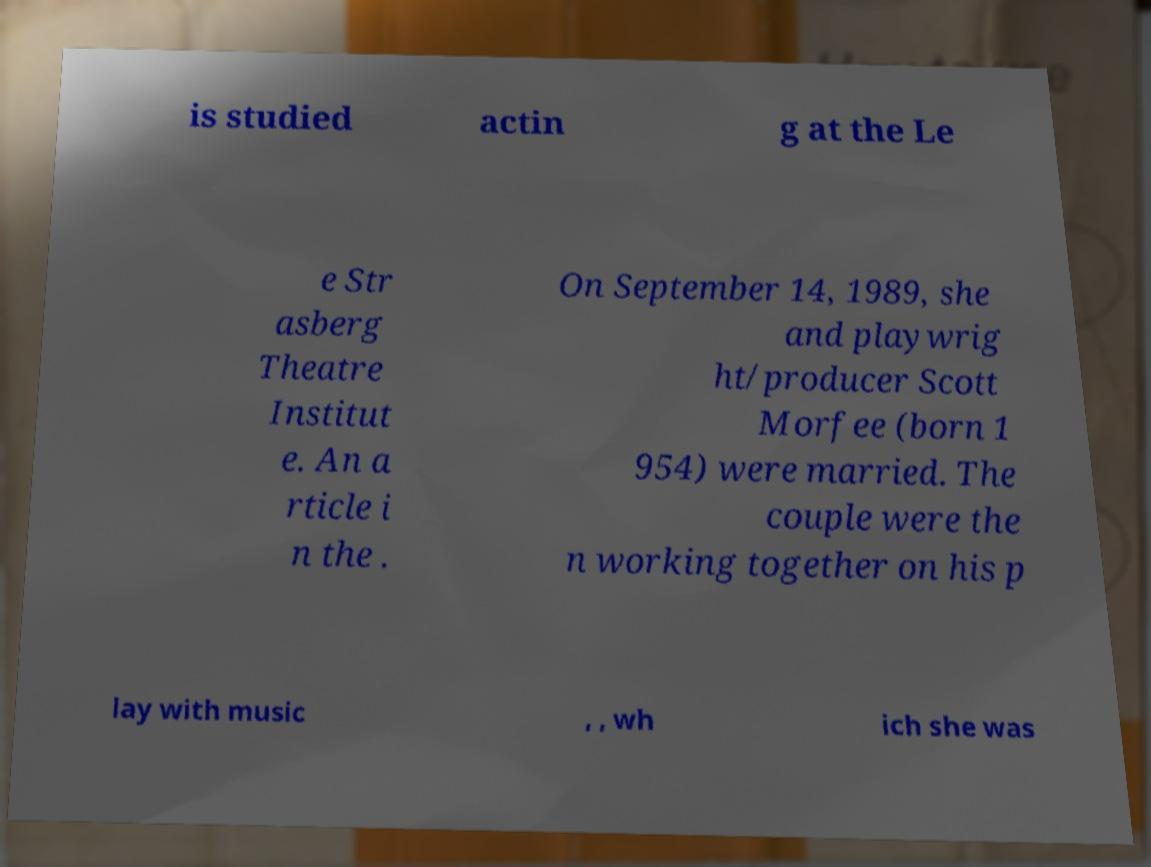There's text embedded in this image that I need extracted. Can you transcribe it verbatim? is studied actin g at the Le e Str asberg Theatre Institut e. An a rticle i n the . On September 14, 1989, she and playwrig ht/producer Scott Morfee (born 1 954) were married. The couple were the n working together on his p lay with music , , wh ich she was 